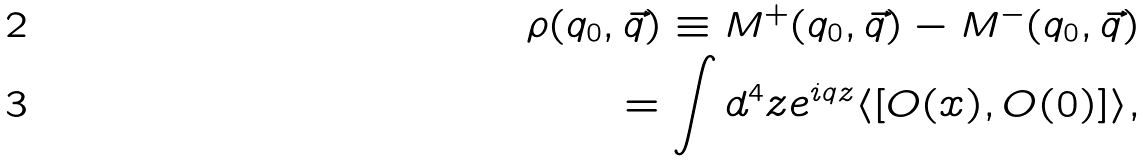<formula> <loc_0><loc_0><loc_500><loc_500>\rho ( q _ { 0 } , \vec { q } ) \equiv M ^ { + } ( q _ { 0 } , \vec { q } ) - M ^ { - } ( q _ { 0 } , \vec { q } ) \\ = \int d ^ { 4 } z e ^ { i q z } \langle [ O ( x ) , O ( 0 ) ] \rangle ,</formula> 